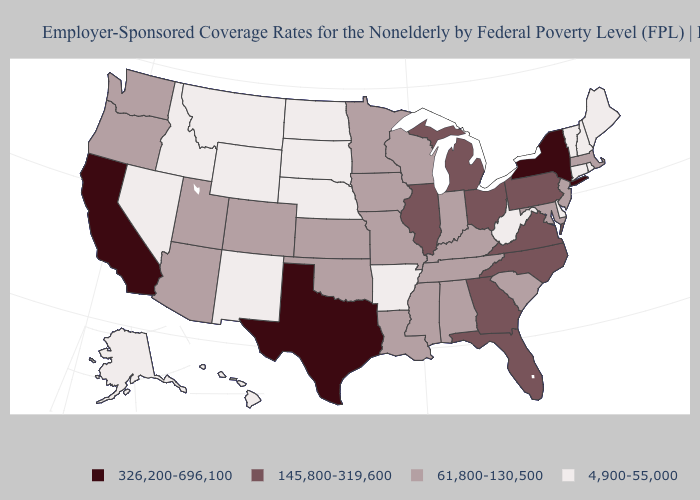What is the value of North Dakota?
Give a very brief answer. 4,900-55,000. Name the states that have a value in the range 145,800-319,600?
Quick response, please. Florida, Georgia, Illinois, Michigan, North Carolina, Ohio, Pennsylvania, Virginia. Name the states that have a value in the range 326,200-696,100?
Give a very brief answer. California, New York, Texas. Does the map have missing data?
Write a very short answer. No. What is the value of Oklahoma?
Give a very brief answer. 61,800-130,500. Name the states that have a value in the range 326,200-696,100?
Be succinct. California, New York, Texas. Name the states that have a value in the range 326,200-696,100?
Short answer required. California, New York, Texas. Name the states that have a value in the range 145,800-319,600?
Short answer required. Florida, Georgia, Illinois, Michigan, North Carolina, Ohio, Pennsylvania, Virginia. Does the first symbol in the legend represent the smallest category?
Quick response, please. No. What is the value of Florida?
Quick response, please. 145,800-319,600. What is the value of Missouri?
Give a very brief answer. 61,800-130,500. Name the states that have a value in the range 326,200-696,100?
Short answer required. California, New York, Texas. Name the states that have a value in the range 145,800-319,600?
Concise answer only. Florida, Georgia, Illinois, Michigan, North Carolina, Ohio, Pennsylvania, Virginia. Does Utah have the highest value in the USA?
Answer briefly. No. Name the states that have a value in the range 145,800-319,600?
Answer briefly. Florida, Georgia, Illinois, Michigan, North Carolina, Ohio, Pennsylvania, Virginia. 